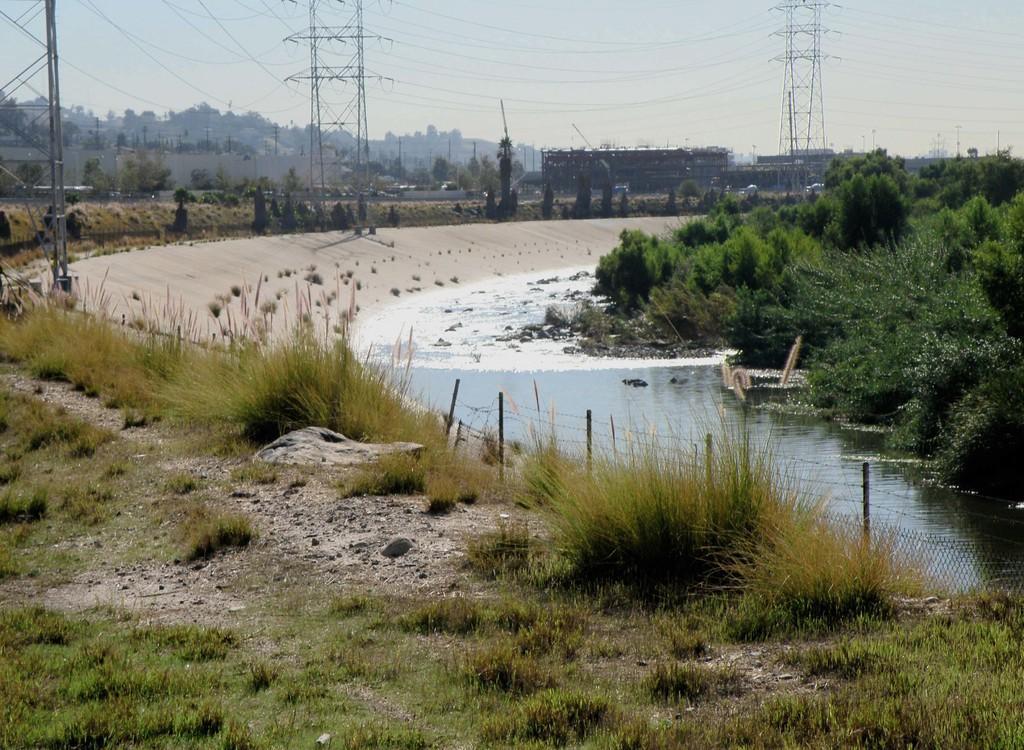In one or two sentences, can you explain what this image depicts? In this image there is a drainage in the middle. Beside that there are trees. In the background there are towers with the wires. On the left side there is a ground on which there are grass and stones. At the top there is sky. 